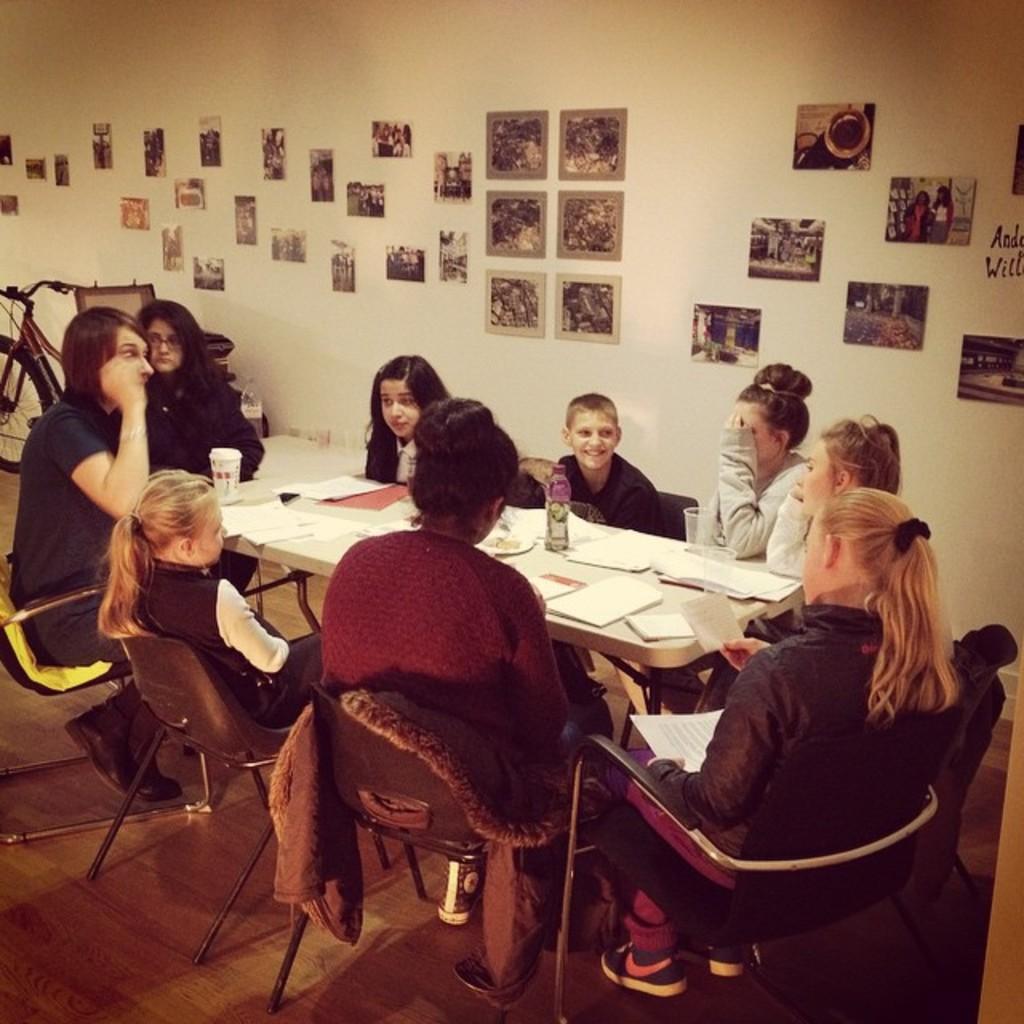Could you give a brief overview of what you see in this image? In this image we can see this people are sitting around the table. We can see papers, glasses, bottle and tin on the table. In the background we can see many photographs on the wall. 